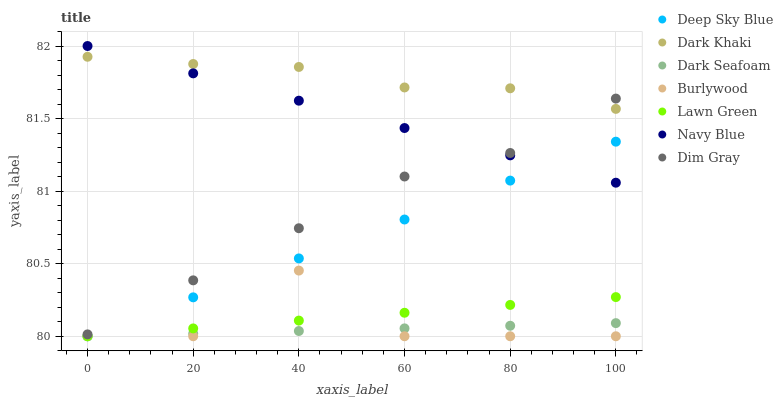Does Dark Seafoam have the minimum area under the curve?
Answer yes or no. Yes. Does Dark Khaki have the maximum area under the curve?
Answer yes or no. Yes. Does Dim Gray have the minimum area under the curve?
Answer yes or no. No. Does Dim Gray have the maximum area under the curve?
Answer yes or no. No. Is Deep Sky Blue the smoothest?
Answer yes or no. Yes. Is Burlywood the roughest?
Answer yes or no. Yes. Is Dim Gray the smoothest?
Answer yes or no. No. Is Dim Gray the roughest?
Answer yes or no. No. Does Lawn Green have the lowest value?
Answer yes or no. Yes. Does Dim Gray have the lowest value?
Answer yes or no. No. Does Navy Blue have the highest value?
Answer yes or no. Yes. Does Dim Gray have the highest value?
Answer yes or no. No. Is Dark Seafoam less than Dim Gray?
Answer yes or no. Yes. Is Dark Khaki greater than Deep Sky Blue?
Answer yes or no. Yes. Does Dark Seafoam intersect Deep Sky Blue?
Answer yes or no. Yes. Is Dark Seafoam less than Deep Sky Blue?
Answer yes or no. No. Is Dark Seafoam greater than Deep Sky Blue?
Answer yes or no. No. Does Dark Seafoam intersect Dim Gray?
Answer yes or no. No. 